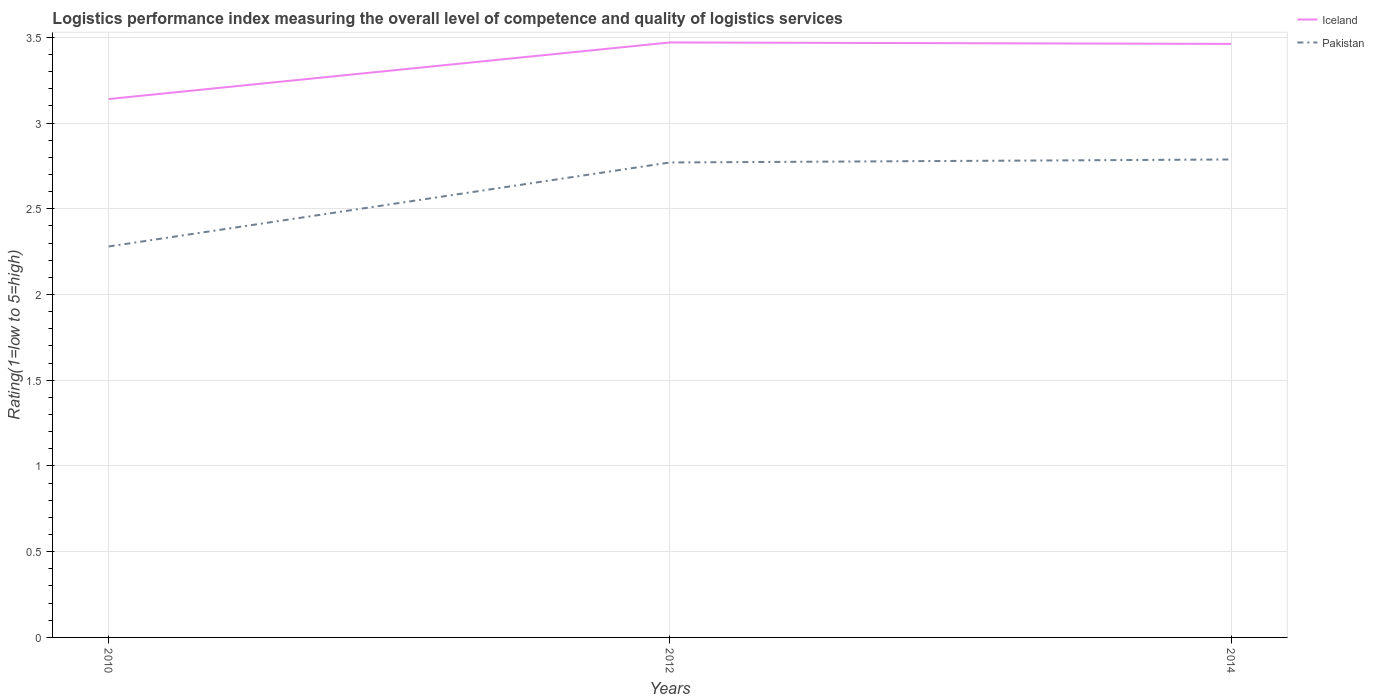How many different coloured lines are there?
Offer a terse response. 2. Does the line corresponding to Iceland intersect with the line corresponding to Pakistan?
Make the answer very short. No. Across all years, what is the maximum Logistic performance index in Pakistan?
Provide a short and direct response. 2.28. What is the total Logistic performance index in Iceland in the graph?
Your answer should be very brief. -0.33. What is the difference between the highest and the second highest Logistic performance index in Pakistan?
Make the answer very short. 0.51. What is the difference between the highest and the lowest Logistic performance index in Iceland?
Your answer should be very brief. 2. Is the Logistic performance index in Pakistan strictly greater than the Logistic performance index in Iceland over the years?
Your answer should be compact. Yes. How many lines are there?
Your answer should be compact. 2. What is the difference between two consecutive major ticks on the Y-axis?
Your answer should be compact. 0.5. Are the values on the major ticks of Y-axis written in scientific E-notation?
Offer a terse response. No. Does the graph contain grids?
Provide a succinct answer. Yes. How are the legend labels stacked?
Ensure brevity in your answer.  Vertical. What is the title of the graph?
Provide a succinct answer. Logistics performance index measuring the overall level of competence and quality of logistics services. What is the label or title of the Y-axis?
Offer a terse response. Rating(1=low to 5=high). What is the Rating(1=low to 5=high) of Iceland in 2010?
Provide a short and direct response. 3.14. What is the Rating(1=low to 5=high) of Pakistan in 2010?
Provide a succinct answer. 2.28. What is the Rating(1=low to 5=high) of Iceland in 2012?
Your answer should be very brief. 3.47. What is the Rating(1=low to 5=high) in Pakistan in 2012?
Your answer should be compact. 2.77. What is the Rating(1=low to 5=high) of Iceland in 2014?
Your answer should be very brief. 3.46. What is the Rating(1=low to 5=high) in Pakistan in 2014?
Offer a terse response. 2.79. Across all years, what is the maximum Rating(1=low to 5=high) of Iceland?
Your answer should be very brief. 3.47. Across all years, what is the maximum Rating(1=low to 5=high) of Pakistan?
Provide a short and direct response. 2.79. Across all years, what is the minimum Rating(1=low to 5=high) of Iceland?
Provide a succinct answer. 3.14. Across all years, what is the minimum Rating(1=low to 5=high) in Pakistan?
Offer a terse response. 2.28. What is the total Rating(1=low to 5=high) in Iceland in the graph?
Ensure brevity in your answer.  10.07. What is the total Rating(1=low to 5=high) of Pakistan in the graph?
Ensure brevity in your answer.  7.84. What is the difference between the Rating(1=low to 5=high) in Iceland in 2010 and that in 2012?
Keep it short and to the point. -0.33. What is the difference between the Rating(1=low to 5=high) of Pakistan in 2010 and that in 2012?
Ensure brevity in your answer.  -0.49. What is the difference between the Rating(1=low to 5=high) in Iceland in 2010 and that in 2014?
Offer a terse response. -0.32. What is the difference between the Rating(1=low to 5=high) of Pakistan in 2010 and that in 2014?
Offer a terse response. -0.51. What is the difference between the Rating(1=low to 5=high) of Iceland in 2012 and that in 2014?
Provide a succinct answer. 0.01. What is the difference between the Rating(1=low to 5=high) in Pakistan in 2012 and that in 2014?
Ensure brevity in your answer.  -0.02. What is the difference between the Rating(1=low to 5=high) in Iceland in 2010 and the Rating(1=low to 5=high) in Pakistan in 2012?
Provide a succinct answer. 0.37. What is the difference between the Rating(1=low to 5=high) in Iceland in 2010 and the Rating(1=low to 5=high) in Pakistan in 2014?
Offer a very short reply. 0.35. What is the difference between the Rating(1=low to 5=high) of Iceland in 2012 and the Rating(1=low to 5=high) of Pakistan in 2014?
Make the answer very short. 0.68. What is the average Rating(1=low to 5=high) of Iceland per year?
Provide a short and direct response. 3.36. What is the average Rating(1=low to 5=high) of Pakistan per year?
Give a very brief answer. 2.61. In the year 2010, what is the difference between the Rating(1=low to 5=high) in Iceland and Rating(1=low to 5=high) in Pakistan?
Make the answer very short. 0.86. In the year 2014, what is the difference between the Rating(1=low to 5=high) of Iceland and Rating(1=low to 5=high) of Pakistan?
Provide a succinct answer. 0.67. What is the ratio of the Rating(1=low to 5=high) in Iceland in 2010 to that in 2012?
Your answer should be compact. 0.9. What is the ratio of the Rating(1=low to 5=high) of Pakistan in 2010 to that in 2012?
Ensure brevity in your answer.  0.82. What is the ratio of the Rating(1=low to 5=high) of Iceland in 2010 to that in 2014?
Make the answer very short. 0.91. What is the ratio of the Rating(1=low to 5=high) in Pakistan in 2010 to that in 2014?
Ensure brevity in your answer.  0.82. What is the ratio of the Rating(1=low to 5=high) in Iceland in 2012 to that in 2014?
Offer a very short reply. 1. What is the difference between the highest and the second highest Rating(1=low to 5=high) in Iceland?
Your response must be concise. 0.01. What is the difference between the highest and the second highest Rating(1=low to 5=high) in Pakistan?
Provide a short and direct response. 0.02. What is the difference between the highest and the lowest Rating(1=low to 5=high) in Iceland?
Your answer should be compact. 0.33. What is the difference between the highest and the lowest Rating(1=low to 5=high) of Pakistan?
Your answer should be compact. 0.51. 